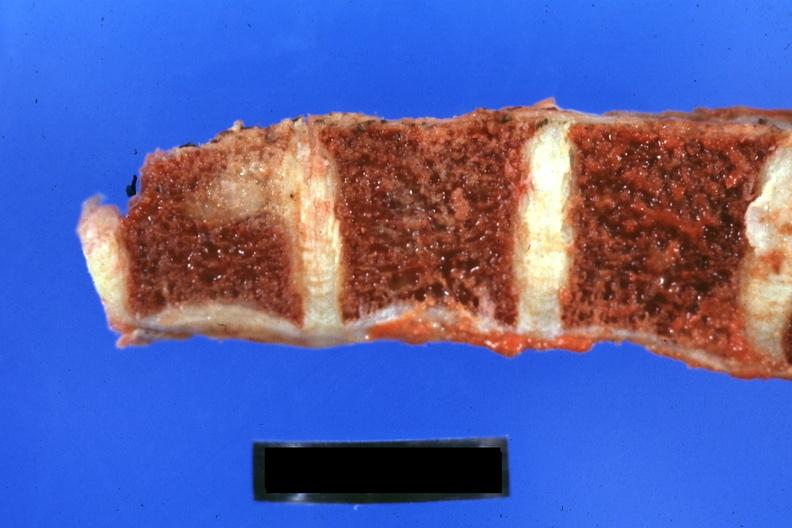what is obvious metastatic lesion 44yobfadenocarcinoma of lung giant cell type occurring?
Answer the question using a single word or phrase. After she was treat-ed for hodgkins disease 